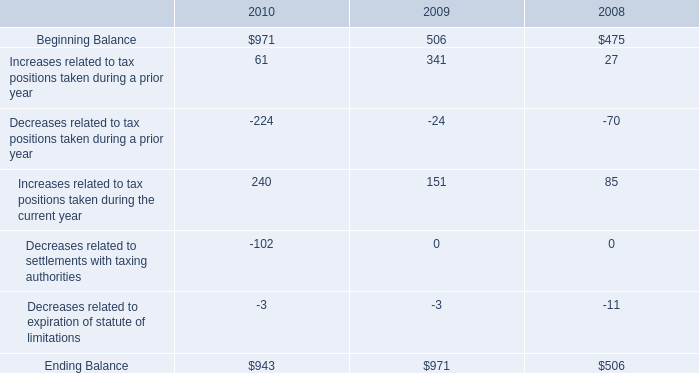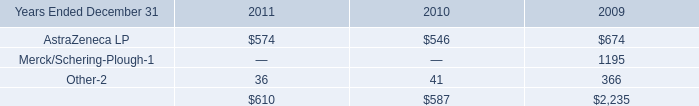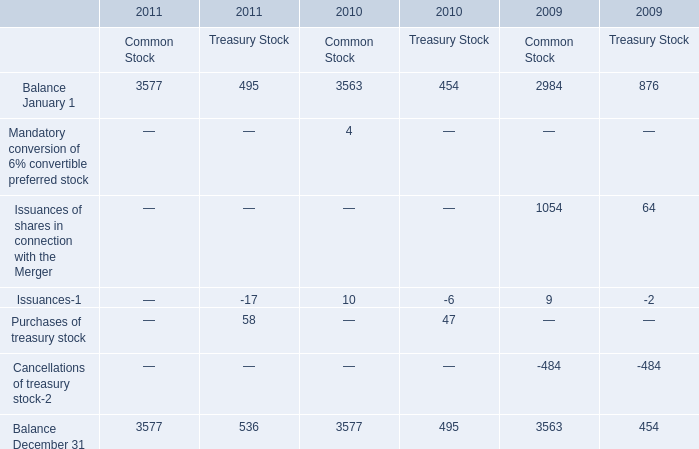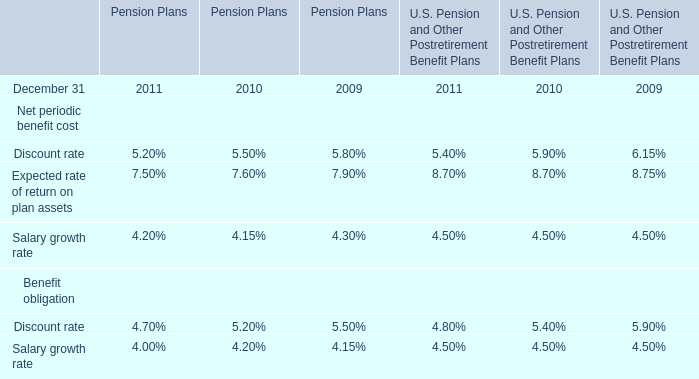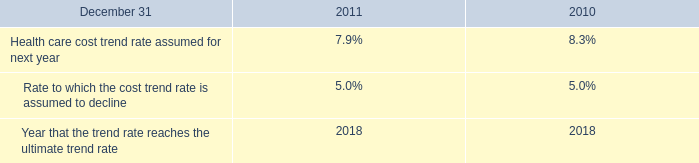What do all elements for Common Stock sum up, excluding those negative ones in 2009? 
Computations: ((2984 + 1054) + 9)
Answer: 4047.0. 